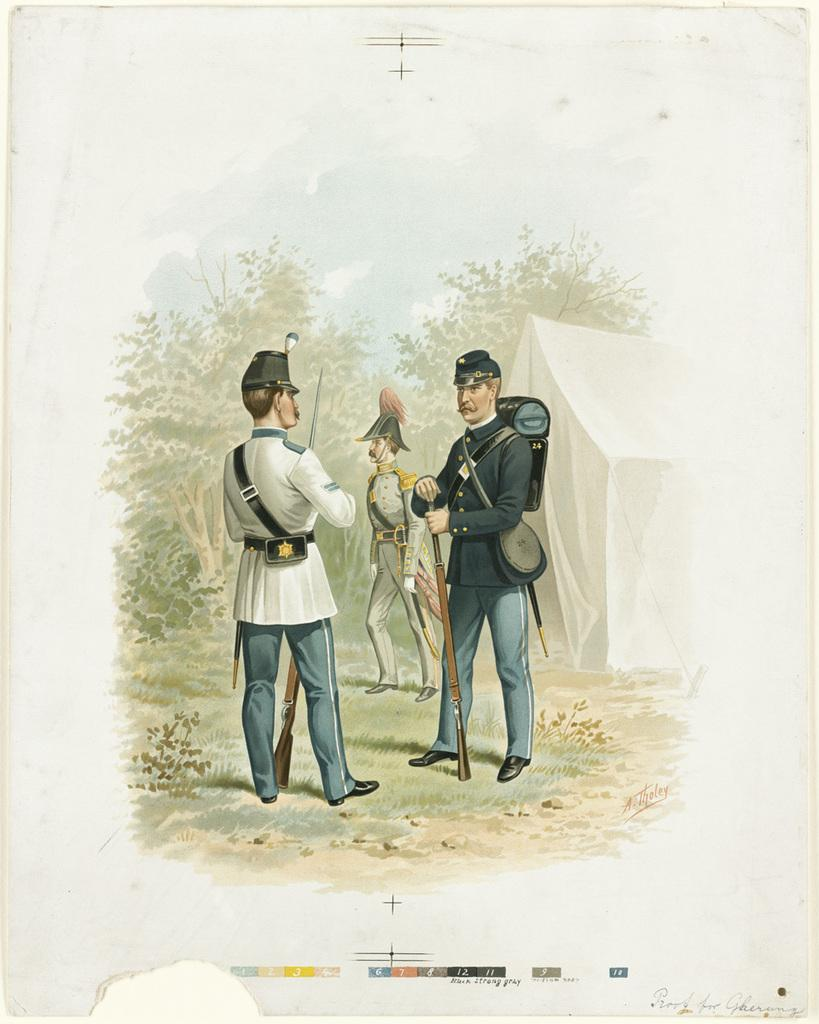What is the subject of the painting? The painting depicts three men. What are the men wearing on their heads? The men are wearing caps. What are the men holding in their hands? The men are holding guns in their hands. Where are the men standing in the painting? The men are standing on the ground. What type of vegetation can be seen in the painting? Trees are present in the painting. What type of shelter is visible in the painting? There is a tent in the painting. What part of the natural environment is visible in the painting? The sky is visible in the painting. What color of paint is being used by the men in the painting? The painting is not a representation of real people but rather a two-dimensional artwork, so there is no paint being used by the men in the image. What type of discussion is taking place between the men in the painting? There is no indication of a discussion taking place between the men in the painting, as they are depicted holding guns and wearing caps. 